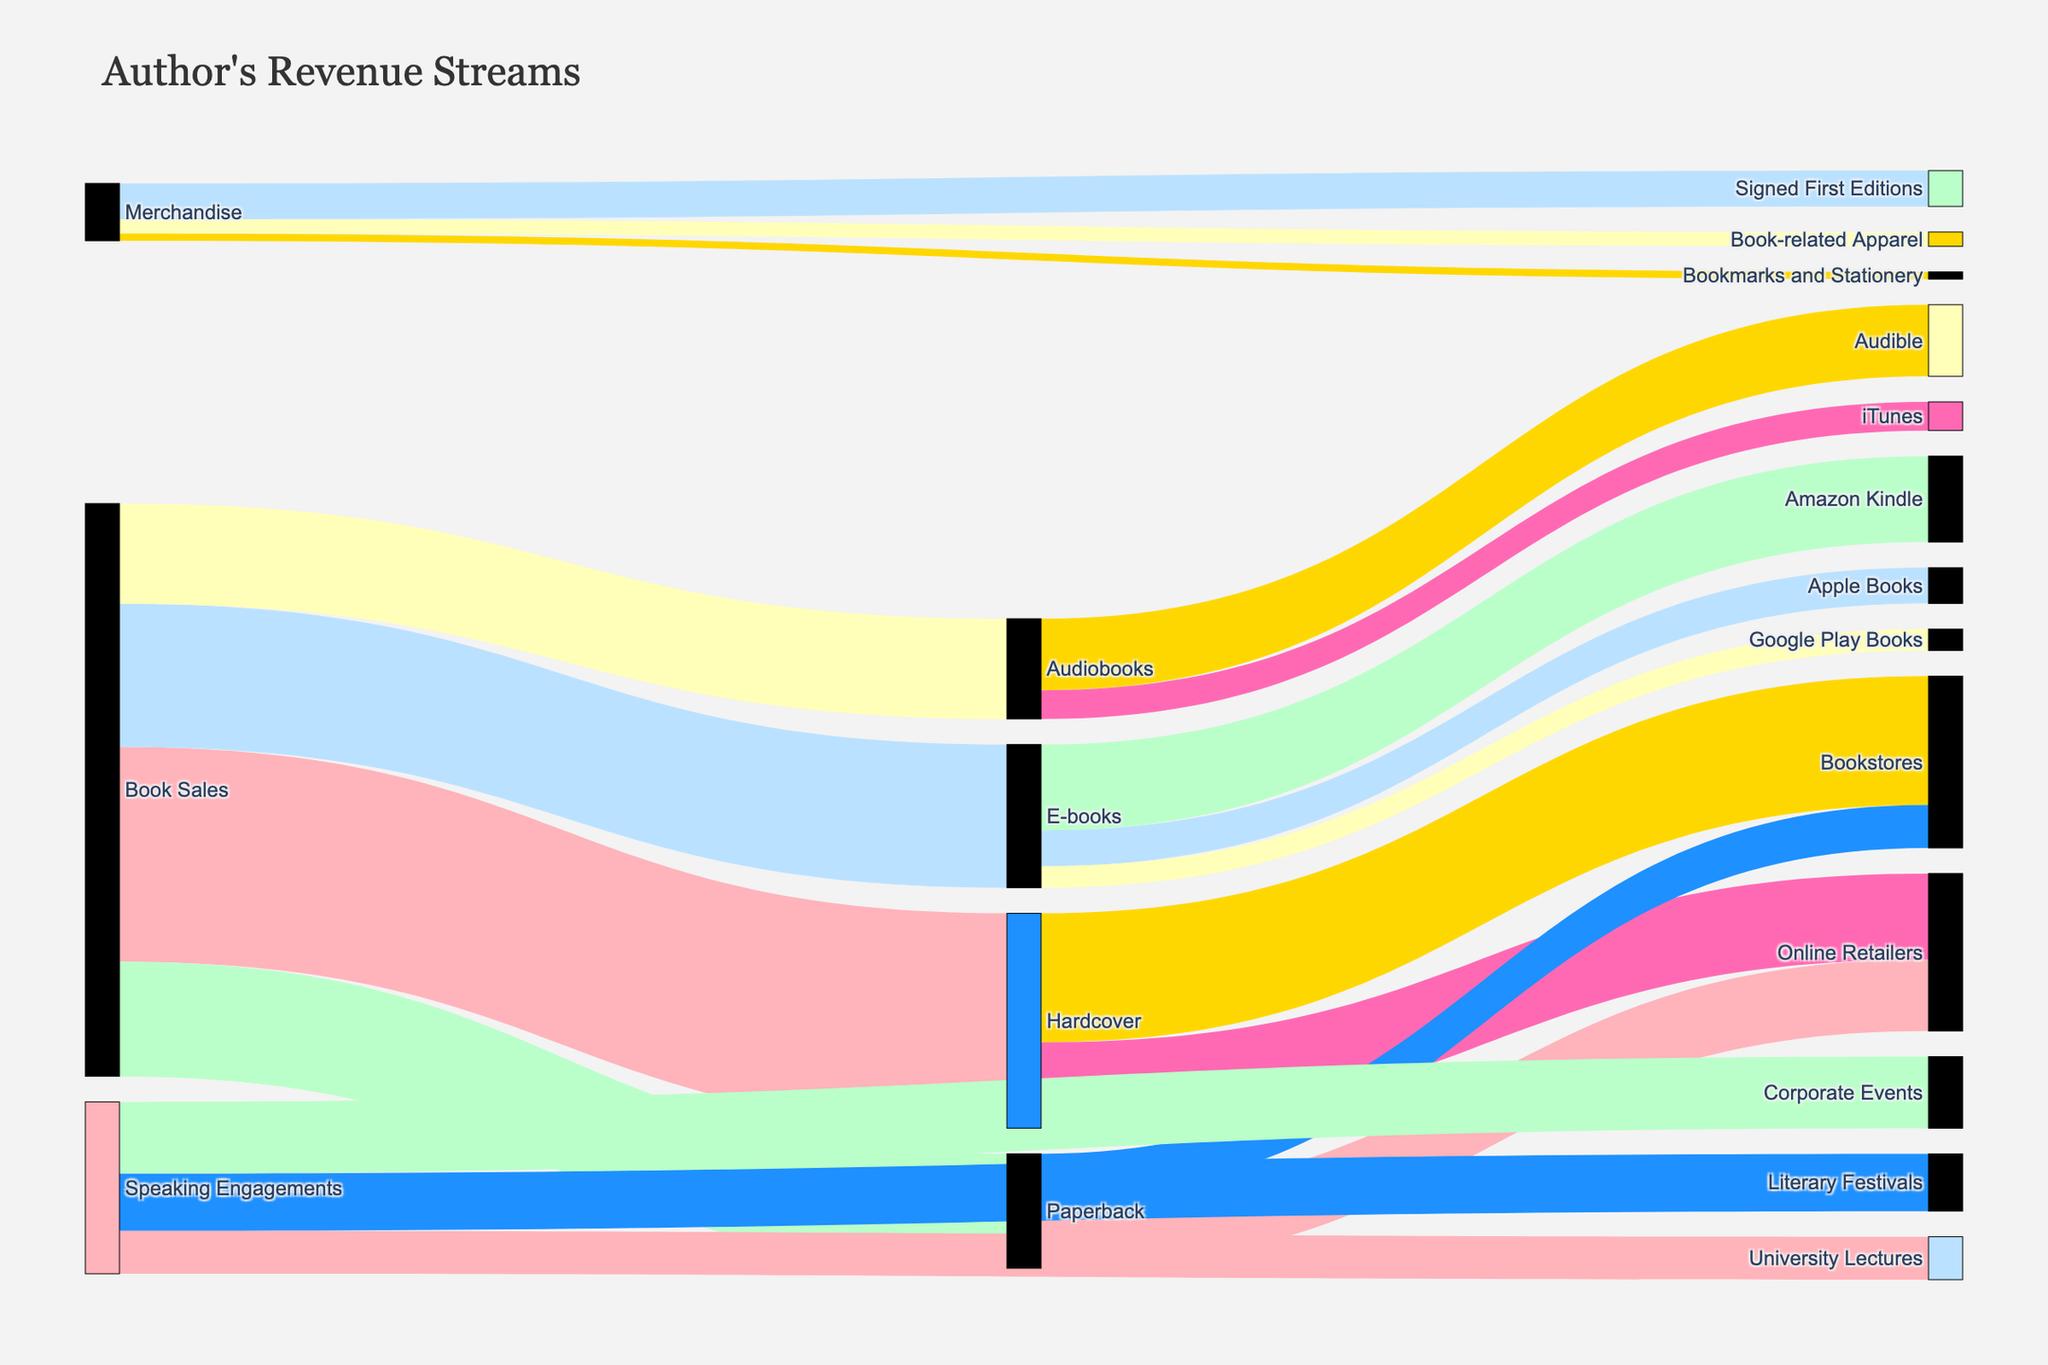What's the title of the figure? The title of the figure is located at the top, usually centered in larger font size, and it summarizes what the figure represents. In this case, it is "Author's Revenue Streams".
Answer: Author's Revenue Streams How much revenue is generated from Book Sales overall? To determine the total revenue from Book Sales, sum the values associated with each target category within Book Sales (Hardcover, Paperback, E-books, Audiobooks). The calculation is 150,000 + 80,000 + 100,000 + 70,000.
Answer: 400,000 Which revenue stream contributes the most to the Author's revenue? To identify the largest revenue stream, compare the values for each main source (Book Sales, Speaking Engagements, Merchandise). Sum the amounts linked to each source: Book Sales (400,000), Speaking Engagements (120,000), Merchandise (40,000).
Answer: Book Sales How much revenue is generated from Online Retailers for both Hardcover and Paperback book sales combined? Sum the values for Online Retailers linked to both Hardcover and Paperback categories. The relevant values are for Hardcover (60,000) and Paperback (50,000).
Answer: 110,000 What are the three main subcategories of revenue within Merchandise? The subcategories of revenue within Merchandise are identified by the target labels. In this case, they are Signed First Editions, Book-related Apparel, and Bookmarks and Stationery.
Answer: Signed First Editions, Book-related Apparel, and Bookmarks and Stationery How much revenue is generated from E-books on Apple Books? Look for the value associated with E-books and Apple Books. The specific value is mentioned directly in the figure.
Answer: 25,000 Compare the total revenue from Hardcover book sales to the total revenue from Audiobooks. Which one is higher and by how much? Sum the values linked to Hardcover and compare them to the total for Audiobooks. Hardcover has 150,000 in total, while Audiobooks have 70,000. The difference is found by subtracting 70,000 from 150,000.
Answer: Hardcover is higher by 80,000 What's the total revenue from Speaking Engagements? Total the values linked to the Speaking Engagements categories. The values are Literary Festivals (40,000), University Lectures (30,000), and Corporate Events (50,000). Summing these gives the total.
Answer: 120,000 What generates more revenue: Signed First Editions or University Lectures? Compare the individual revenue values of Signed First Editions (25,000) and University Lectures (30,000). Identify which value is higher.
Answer: University Lectures What is the average revenue generated by the three types of book sales formats under Book Sales (Hardcover, Paperback, E-books, Audiobooks)? To find the average revenue per book format, sum the values (150,000 for Hardcover, 80,000 for Paperback, 100,000 for E-books, and 70,000 for Audiobooks), then divide by the number of formats (4).
Answer: 100,000 